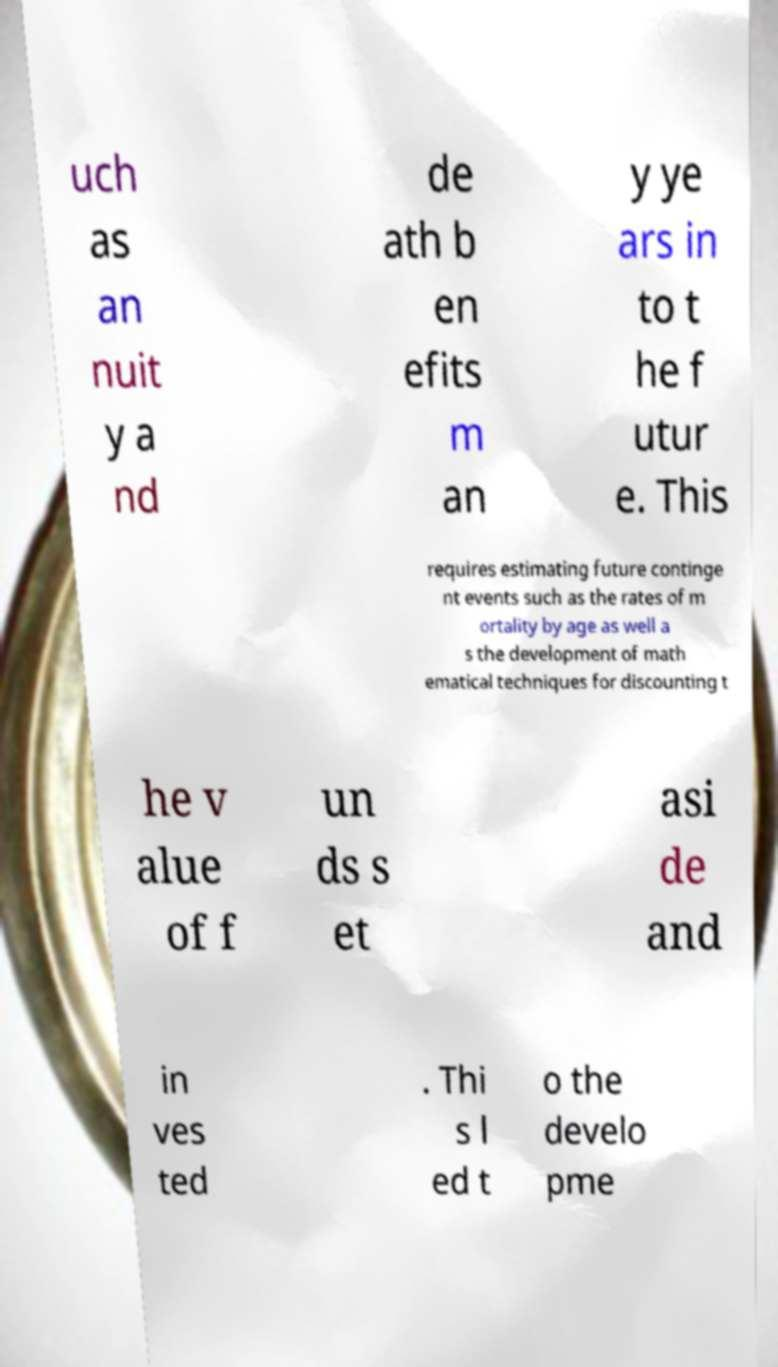Can you read and provide the text displayed in the image?This photo seems to have some interesting text. Can you extract and type it out for me? uch as an nuit y a nd de ath b en efits m an y ye ars in to t he f utur e. This requires estimating future continge nt events such as the rates of m ortality by age as well a s the development of math ematical techniques for discounting t he v alue of f un ds s et asi de and in ves ted . Thi s l ed t o the develo pme 